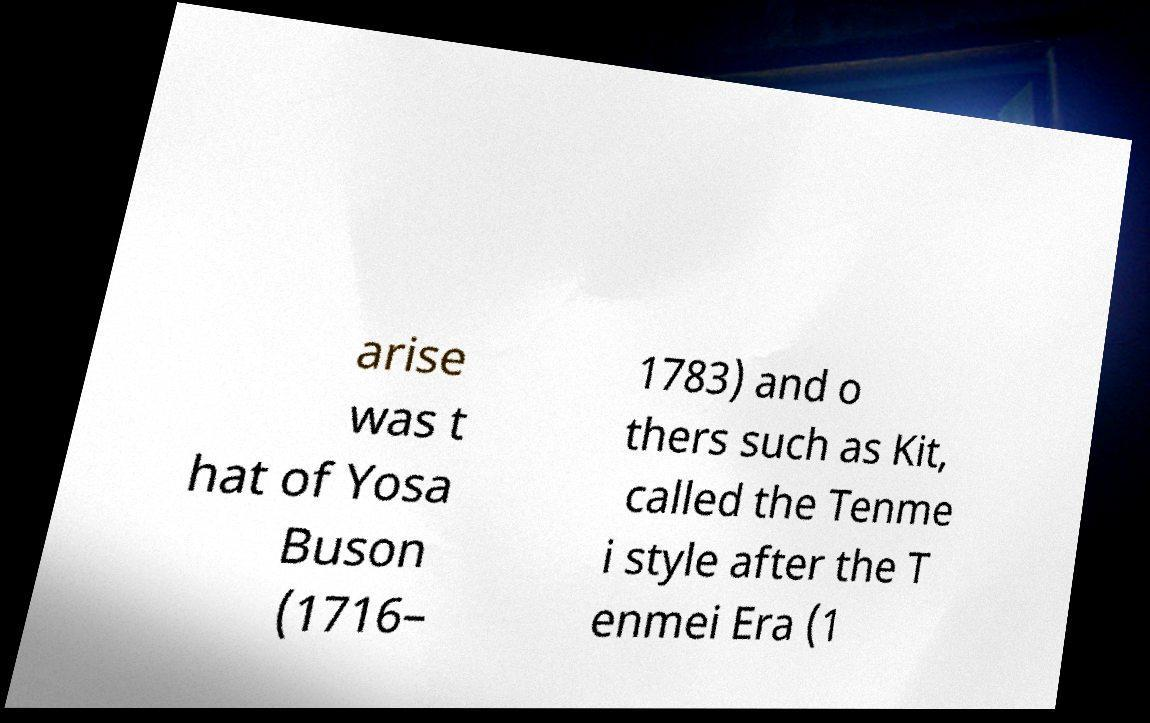I need the written content from this picture converted into text. Can you do that? arise was t hat of Yosa Buson (1716– 1783) and o thers such as Kit, called the Tenme i style after the T enmei Era (1 